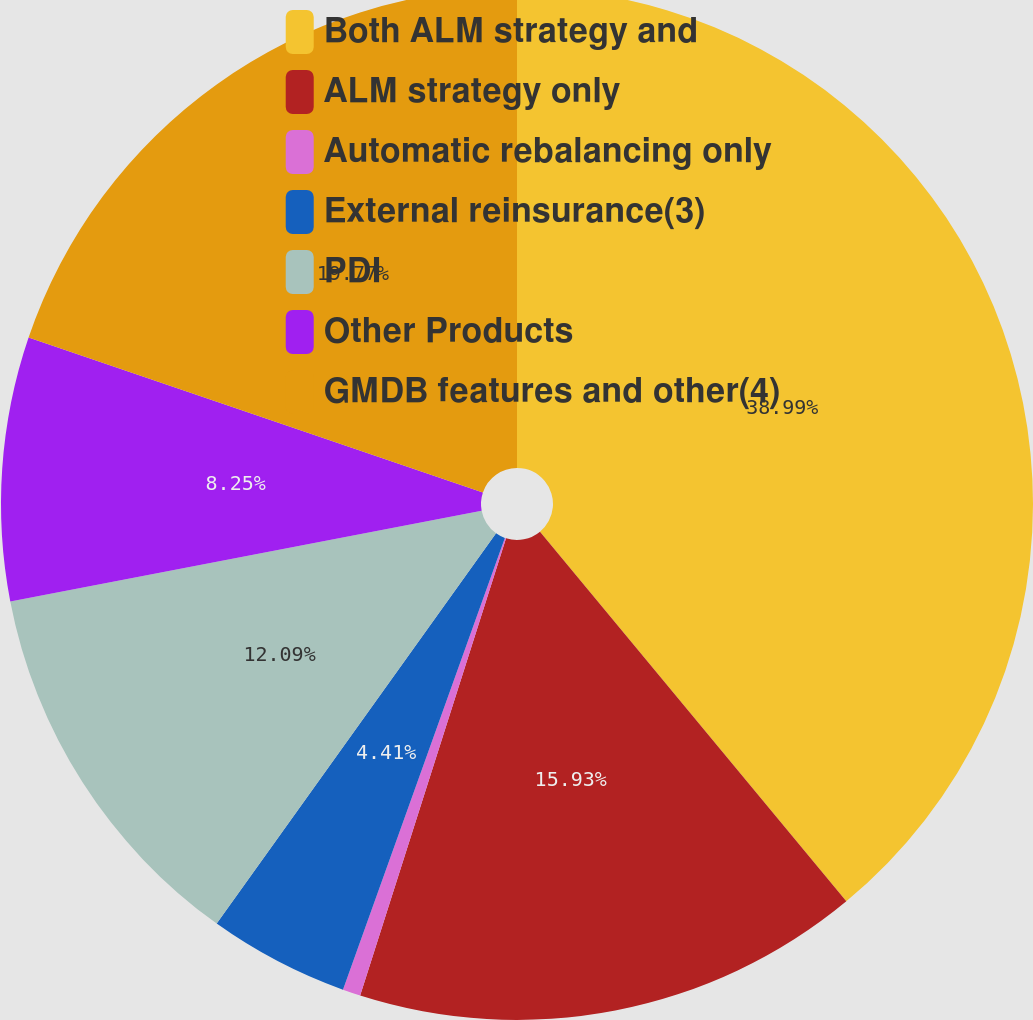Convert chart to OTSL. <chart><loc_0><loc_0><loc_500><loc_500><pie_chart><fcel>Both ALM strategy and<fcel>ALM strategy only<fcel>Automatic rebalancing only<fcel>External reinsurance(3)<fcel>PDI<fcel>Other Products<fcel>GMDB features and other(4)<nl><fcel>38.98%<fcel>15.93%<fcel>0.56%<fcel>4.41%<fcel>12.09%<fcel>8.25%<fcel>19.77%<nl></chart> 